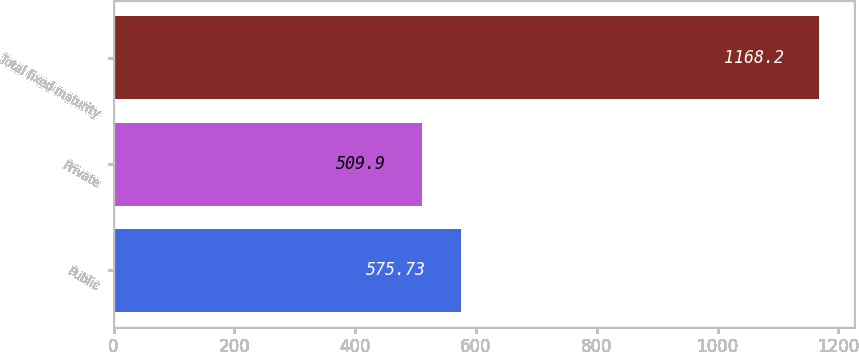<chart> <loc_0><loc_0><loc_500><loc_500><bar_chart><fcel>Public<fcel>Private<fcel>Total fixed maturity<nl><fcel>575.73<fcel>509.9<fcel>1168.2<nl></chart> 